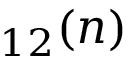Convert formula to latex. <formula><loc_0><loc_0><loc_500><loc_500>_ { 1 2 } ( n )</formula> 